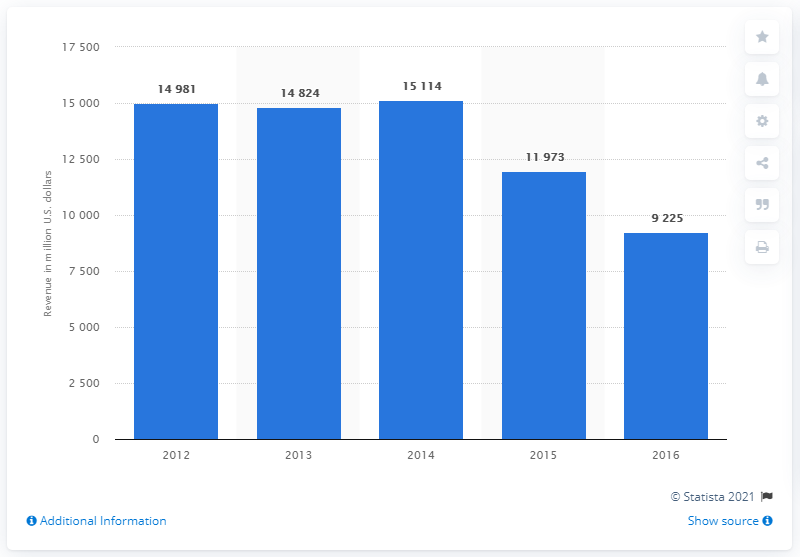Mention a couple of crucial points in this snapshot. Dow Chemical reported that the revenue generated in the Performance Materials & Chemicals segment in 2012 was $151,140. 